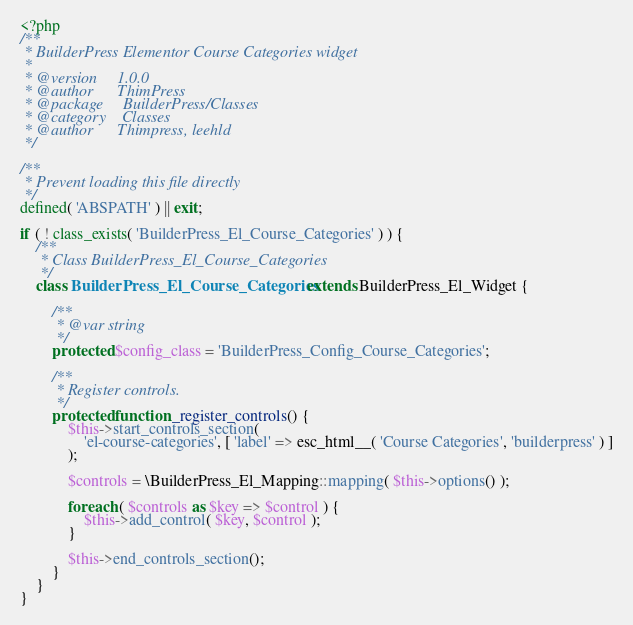Convert code to text. <code><loc_0><loc_0><loc_500><loc_500><_PHP_><?php
/**
 * BuilderPress Elementor Course Categories widget
 *
 * @version     1.0.0
 * @author      ThimPress
 * @package     BuilderPress/Classes
 * @category    Classes
 * @author      Thimpress, leehld
 */

/**
 * Prevent loading this file directly
 */
defined( 'ABSPATH' ) || exit;

if ( ! class_exists( 'BuilderPress_El_Course_Categories' ) ) {
	/**
	 * Class BuilderPress_El_Course_Categories
	 */
	class BuilderPress_El_Course_Categories extends BuilderPress_El_Widget {

		/**
		 * @var string
		 */
		protected $config_class = 'BuilderPress_Config_Course_Categories';

		/**
		 * Register controls.
		 */
		protected function _register_controls() {
			$this->start_controls_section(
				'el-course-categories', [ 'label' => esc_html__( 'Course Categories', 'builderpress' ) ]
			);

			$controls = \BuilderPress_El_Mapping::mapping( $this->options() );

			foreach ( $controls as $key => $control ) {
				$this->add_control( $key, $control );
			}

			$this->end_controls_section();
		}
	}
}</code> 